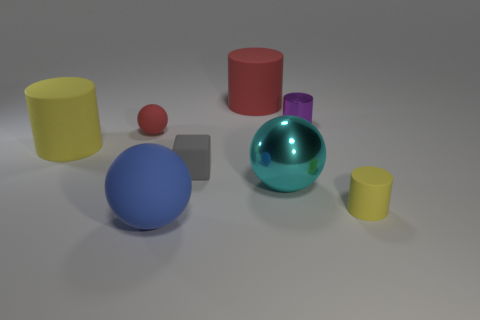Subtract all metallic spheres. How many spheres are left? 2 Subtract all green balls. How many yellow cylinders are left? 2 Subtract 1 cylinders. How many cylinders are left? 3 Add 1 tiny gray things. How many objects exist? 9 Subtract all purple cylinders. How many cylinders are left? 3 Subtract all blocks. How many objects are left? 7 Subtract all purple balls. Subtract all yellow cylinders. How many balls are left? 3 Subtract all tiny purple objects. Subtract all small things. How many objects are left? 3 Add 7 small gray things. How many small gray things are left? 8 Add 5 large blue matte spheres. How many large blue matte spheres exist? 6 